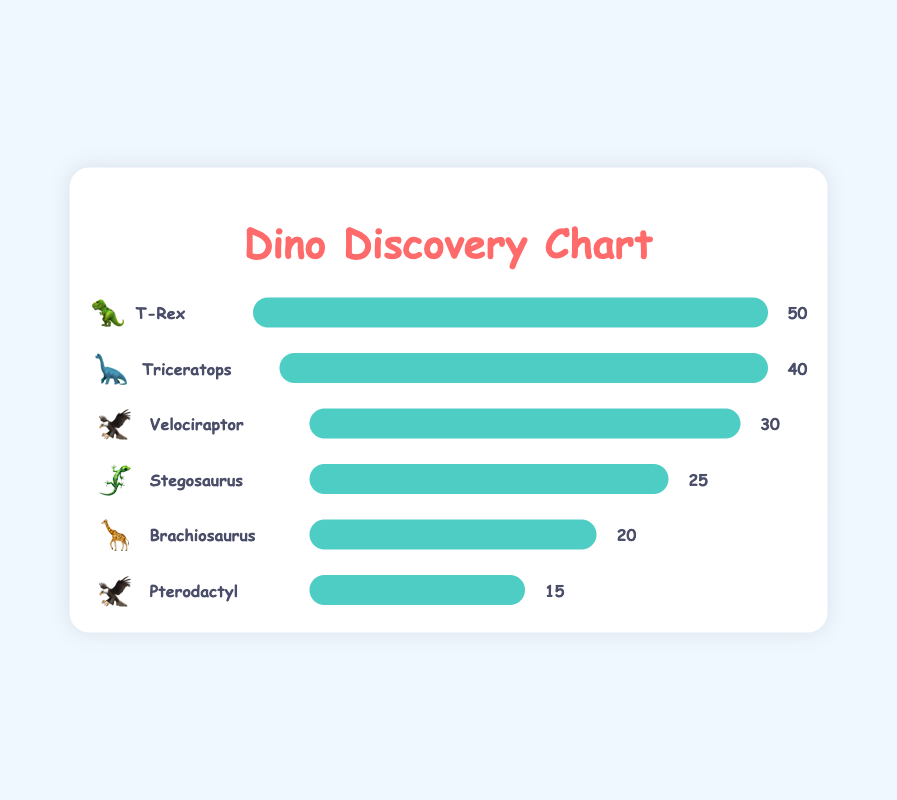What is the title of the figure? The title of the figure is displayed at the top in large, colorful text. It clearly indicates that the chart is about the discovery of different types of dinosaurs.
Answer: Dino Discovery Chart Which dinosaur is represented by the emoji 🦖? Look through the chart to identify the bar that has the emoji 🦖 and see the name next to it.
Answer: T-Rex How many types of dinosaurs are displayed in the chart? Count the number of bars in the chart, each representing a different dinosaur.
Answer: 6 Which dinosaur has the highest count of discoveries? Find the bar with the longest width, representing the dinosaur with the highest count.
Answer: T-Rex Which dinosaur has the fewest discoveries, and what is its count? Identify the bar with the shortest width to find the dinosaur with the fewest discoveries and then read the number next to it.
Answer: Pterodactyl, 15 Compare the discoveries of Stegosaurus and Brachiosaurus. Which one has more, and by how much? Find the counts for both Stegosaurus and Brachiosaurus. Subtract the count of Brachiosaurus from Stegosaurus to get the difference.
Answer: Stegosaurus, by 5 What is the total number of dinosaur discoveries represented in the chart? Add up the counts of all the dinosaurs presented in the chart.
Answer: 180 What is the average number of discoveries per type of dinosaur? Sum the counts of all the dinosaurs and divide by the number of different types.
Answer: 30 By how much does the count of Triceratops discoveries exceed that of Pterodactyl? Subtract the count of Pterodactyl from Triceratops to find the difference.
Answer: 25 Which two dinosaurs have the same emoji, and what is that emoji? Look for any repeated emojis and identify the dinosaurs that share it.
Answer: Velociraptor and Pterodactyl, 🦅 